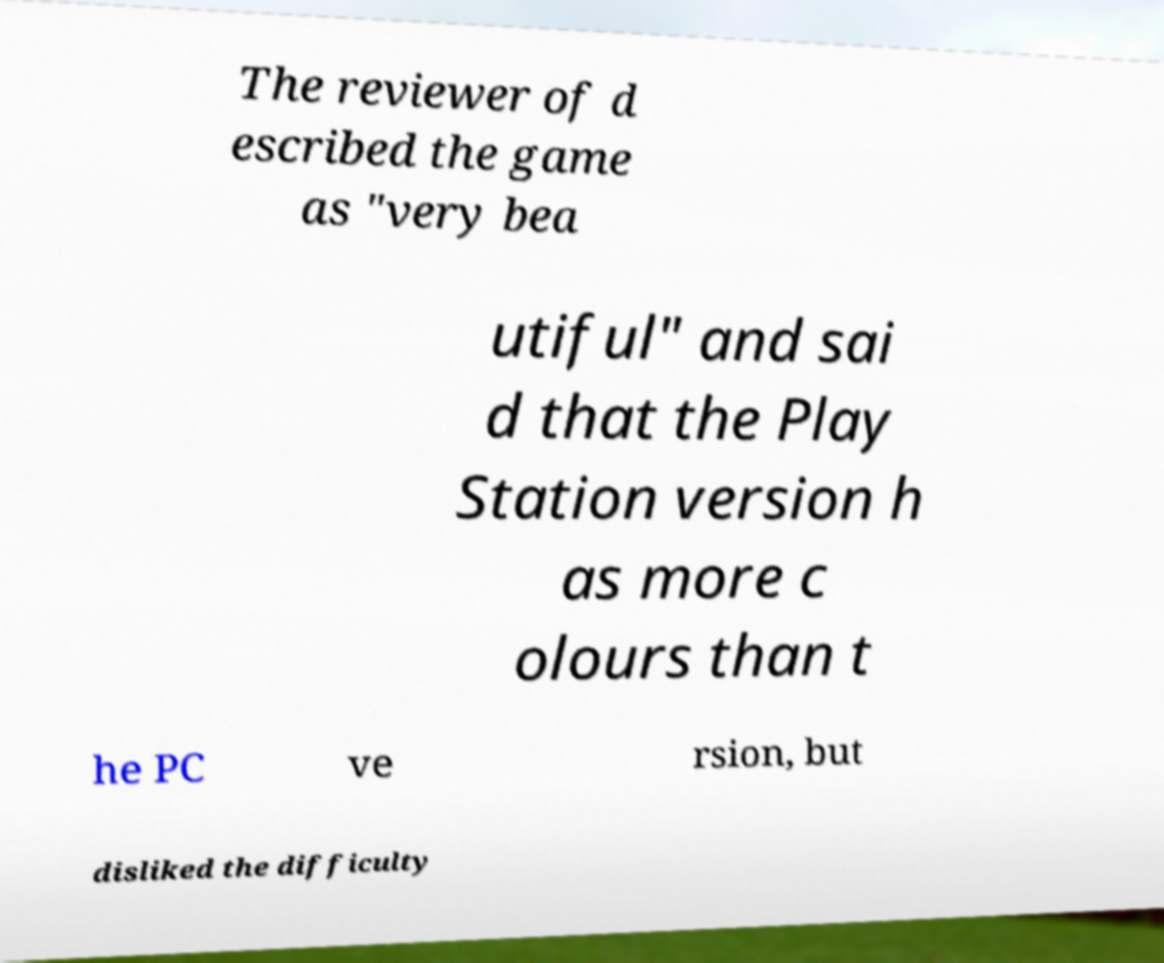For documentation purposes, I need the text within this image transcribed. Could you provide that? The reviewer of d escribed the game as "very bea utiful" and sai d that the Play Station version h as more c olours than t he PC ve rsion, but disliked the difficulty 